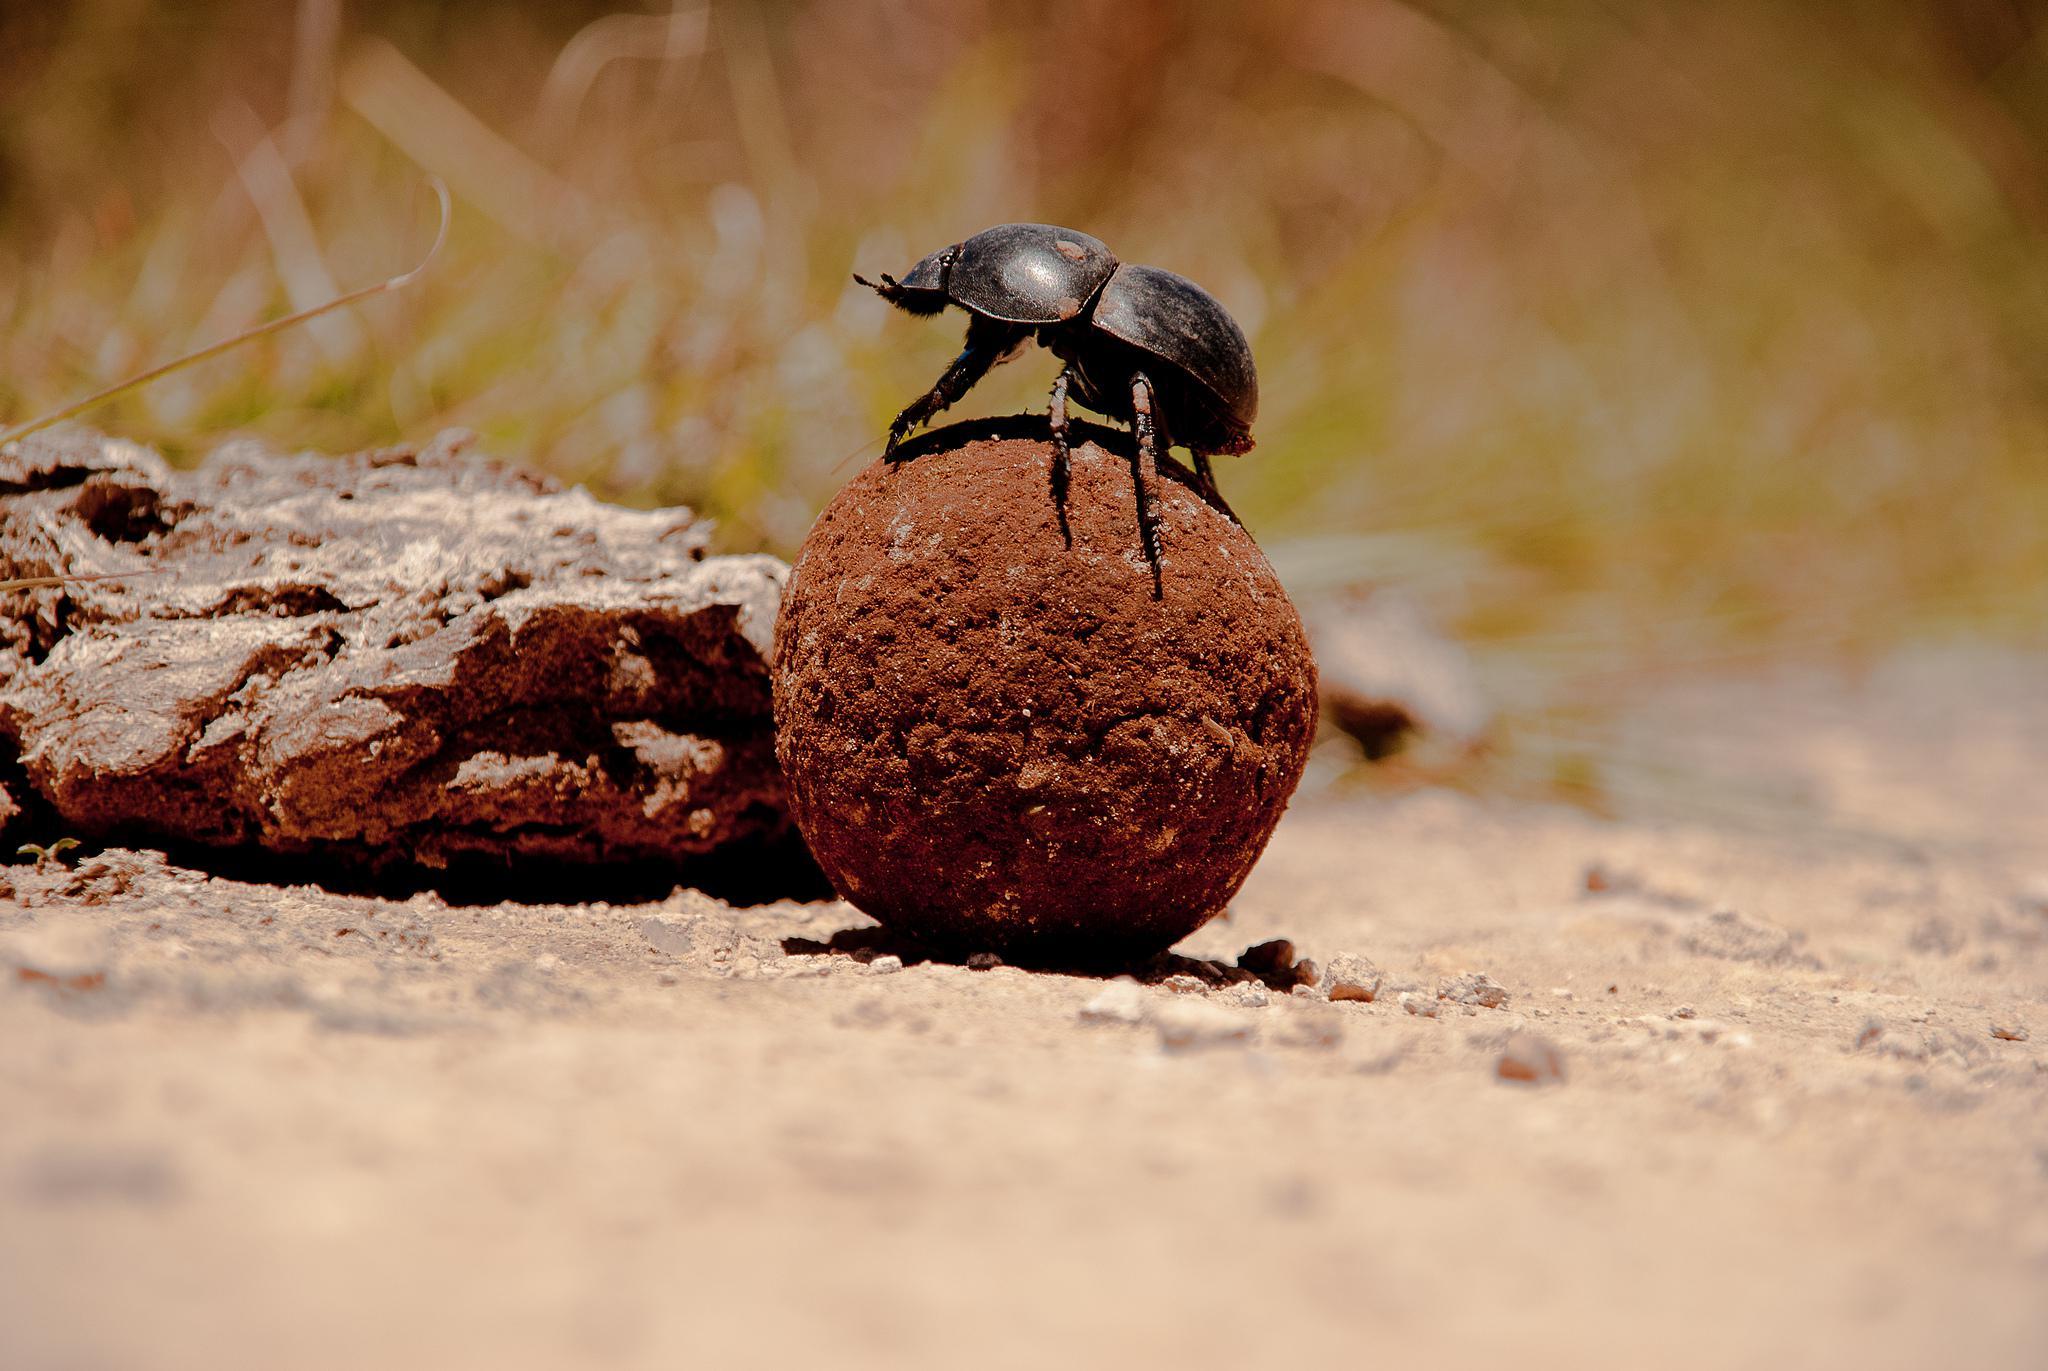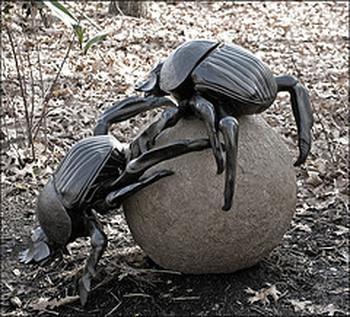The first image is the image on the left, the second image is the image on the right. For the images displayed, is the sentence "Exactly one black beetle is shown in each image with its back appendages on a round rocky particle and at least one front appendage on the ground." factually correct? Answer yes or no. No. The first image is the image on the left, the second image is the image on the right. Considering the images on both sides, is "Each image shows exactly one beetle in contact with one round dung ball." valid? Answer yes or no. No. 